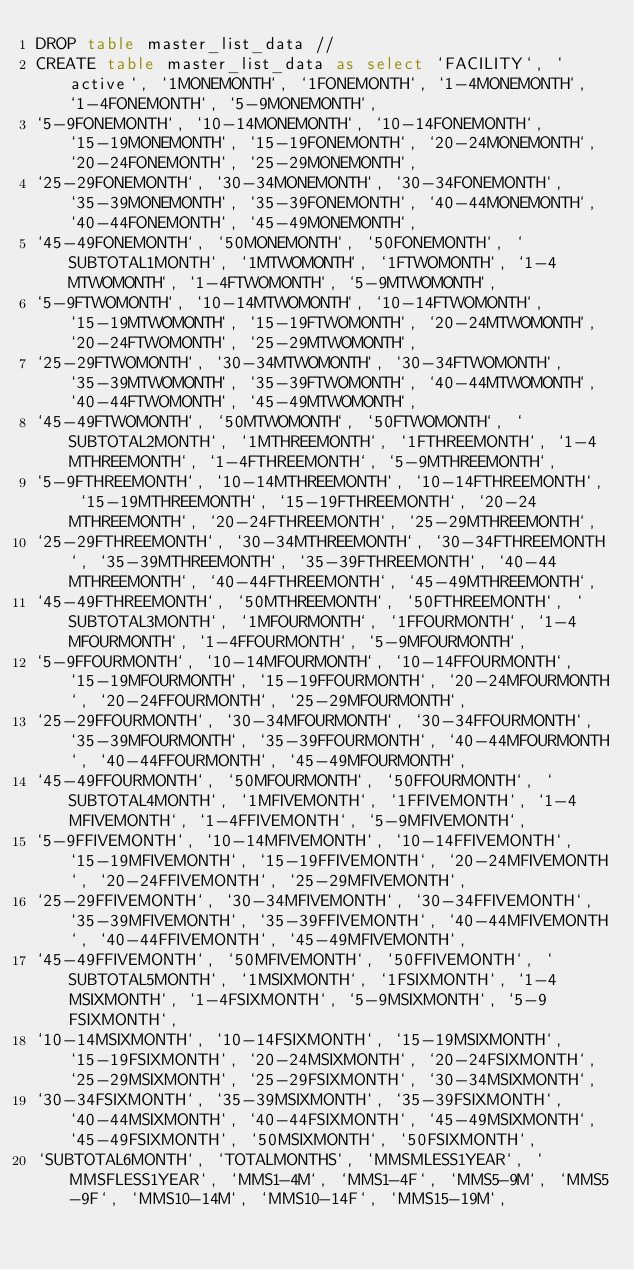<code> <loc_0><loc_0><loc_500><loc_500><_SQL_>DROP table master_list_data //
CREATE table master_list_data as select `FACILITY`, `active`, `1MONEMONTH`, `1FONEMONTH`, `1-4MONEMONTH`, `1-4FONEMONTH`, `5-9MONEMONTH`, 
`5-9FONEMONTH`, `10-14MONEMONTH`, `10-14FONEMONTH`, `15-19MONEMONTH`, `15-19FONEMONTH`, `20-24MONEMONTH`, `20-24FONEMONTH`, `25-29MONEMONTH`, 
`25-29FONEMONTH`, `30-34MONEMONTH`, `30-34FONEMONTH`, `35-39MONEMONTH`, `35-39FONEMONTH`, `40-44MONEMONTH`, `40-44FONEMONTH`, `45-49MONEMONTH`, 
`45-49FONEMONTH`, `50MONEMONTH`, `50FONEMONTH`, `SUBTOTAL1MONTH`, `1MTWOMONTH`, `1FTWOMONTH`, `1-4MTWOMONTH`, `1-4FTWOMONTH`, `5-9MTWOMONTH`, 
`5-9FTWOMONTH`, `10-14MTWOMONTH`, `10-14FTWOMONTH`, `15-19MTWOMONTH`, `15-19FTWOMONTH`, `20-24MTWOMONTH`, `20-24FTWOMONTH`, `25-29MTWOMONTH`, 
`25-29FTWOMONTH`, `30-34MTWOMONTH`, `30-34FTWOMONTH`, `35-39MTWOMONTH`, `35-39FTWOMONTH`, `40-44MTWOMONTH`, `40-44FTWOMONTH`, `45-49MTWOMONTH`, 
`45-49FTWOMONTH`, `50MTWOMONTH`, `50FTWOMONTH`, `SUBTOTAL2MONTH`, `1MTHREEMONTH`, `1FTHREEMONTH`, `1-4MTHREEMONTH`, `1-4FTHREEMONTH`, `5-9MTHREEMONTH`, 
`5-9FTHREEMONTH`, `10-14MTHREEMONTH`, `10-14FTHREEMONTH`, `15-19MTHREEMONTH`, `15-19FTHREEMONTH`, `20-24MTHREEMONTH`, `20-24FTHREEMONTH`, `25-29MTHREEMONTH`, 
`25-29FTHREEMONTH`, `30-34MTHREEMONTH`, `30-34FTHREEMONTH`, `35-39MTHREEMONTH`, `35-39FTHREEMONTH`, `40-44MTHREEMONTH`, `40-44FTHREEMONTH`, `45-49MTHREEMONTH`, 
`45-49FTHREEMONTH`, `50MTHREEMONTH`, `50FTHREEMONTH`, `SUBTOTAL3MONTH`, `1MFOURMONTH`, `1FFOURMONTH`, `1-4MFOURMONTH`, `1-4FFOURMONTH`, `5-9MFOURMONTH`, 
`5-9FFOURMONTH`, `10-14MFOURMONTH`, `10-14FFOURMONTH`, `15-19MFOURMONTH`, `15-19FFOURMONTH`, `20-24MFOURMONTH`, `20-24FFOURMONTH`, `25-29MFOURMONTH`, 
`25-29FFOURMONTH`, `30-34MFOURMONTH`, `30-34FFOURMONTH`, `35-39MFOURMONTH`, `35-39FFOURMONTH`, `40-44MFOURMONTH`, `40-44FFOURMONTH`, `45-49MFOURMONTH`, 
`45-49FFOURMONTH`, `50MFOURMONTH`, `50FFOURMONTH`, `SUBTOTAL4MONTH`, `1MFIVEMONTH`, `1FFIVEMONTH`, `1-4MFIVEMONTH`, `1-4FFIVEMONTH`, `5-9MFIVEMONTH`, 
`5-9FFIVEMONTH`, `10-14MFIVEMONTH`, `10-14FFIVEMONTH`, `15-19MFIVEMONTH`, `15-19FFIVEMONTH`, `20-24MFIVEMONTH`, `20-24FFIVEMONTH`, `25-29MFIVEMONTH`, 
`25-29FFIVEMONTH`, `30-34MFIVEMONTH`, `30-34FFIVEMONTH`, `35-39MFIVEMONTH`, `35-39FFIVEMONTH`, `40-44MFIVEMONTH`, `40-44FFIVEMONTH`, `45-49MFIVEMONTH`, 
`45-49FFIVEMONTH`, `50MFIVEMONTH`, `50FFIVEMONTH`, `SUBTOTAL5MONTH`, `1MSIXMONTH`, `1FSIXMONTH`, `1-4MSIXMONTH`, `1-4FSIXMONTH`, `5-9MSIXMONTH`, `5-9FSIXMONTH`, 
`10-14MSIXMONTH`, `10-14FSIXMONTH`, `15-19MSIXMONTH`, `15-19FSIXMONTH`, `20-24MSIXMONTH`, `20-24FSIXMONTH`, `25-29MSIXMONTH`, `25-29FSIXMONTH`, `30-34MSIXMONTH`, 
`30-34FSIXMONTH`, `35-39MSIXMONTH`, `35-39FSIXMONTH`, `40-44MSIXMONTH`, `40-44FSIXMONTH`, `45-49MSIXMONTH`, `45-49FSIXMONTH`, `50MSIXMONTH`, `50FSIXMONTH`, 
`SUBTOTAL6MONTH`, `TOTALMONTHS`, `MMSMLESS1YEAR`, `MMSFLESS1YEAR`, `MMS1-4M`, `MMS1-4F`, `MMS5-9M`, `MMS5-9F`, `MMS10-14M`, `MMS10-14F`, `MMS15-19M`, </code> 